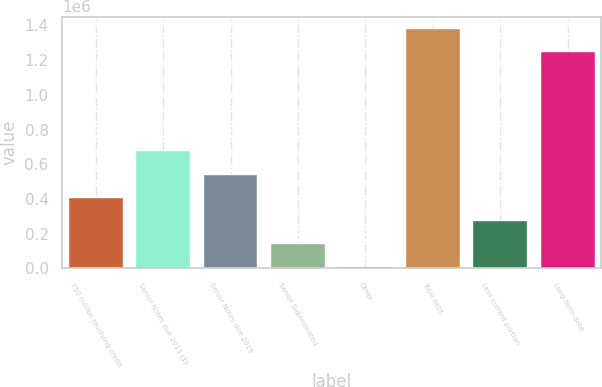Convert chart to OTSL. <chart><loc_0><loc_0><loc_500><loc_500><bar_chart><fcel>750 million revolving credit<fcel>Senior Notes due 2013 (1)<fcel>Senior Notes due 2019<fcel>Senior Subordinated<fcel>Other<fcel>Total debt<fcel>Less current portion<fcel>Long-term debt<nl><fcel>406494<fcel>673508<fcel>540001<fcel>139479<fcel>5972<fcel>1.38121e+06<fcel>272987<fcel>1.2477e+06<nl></chart> 